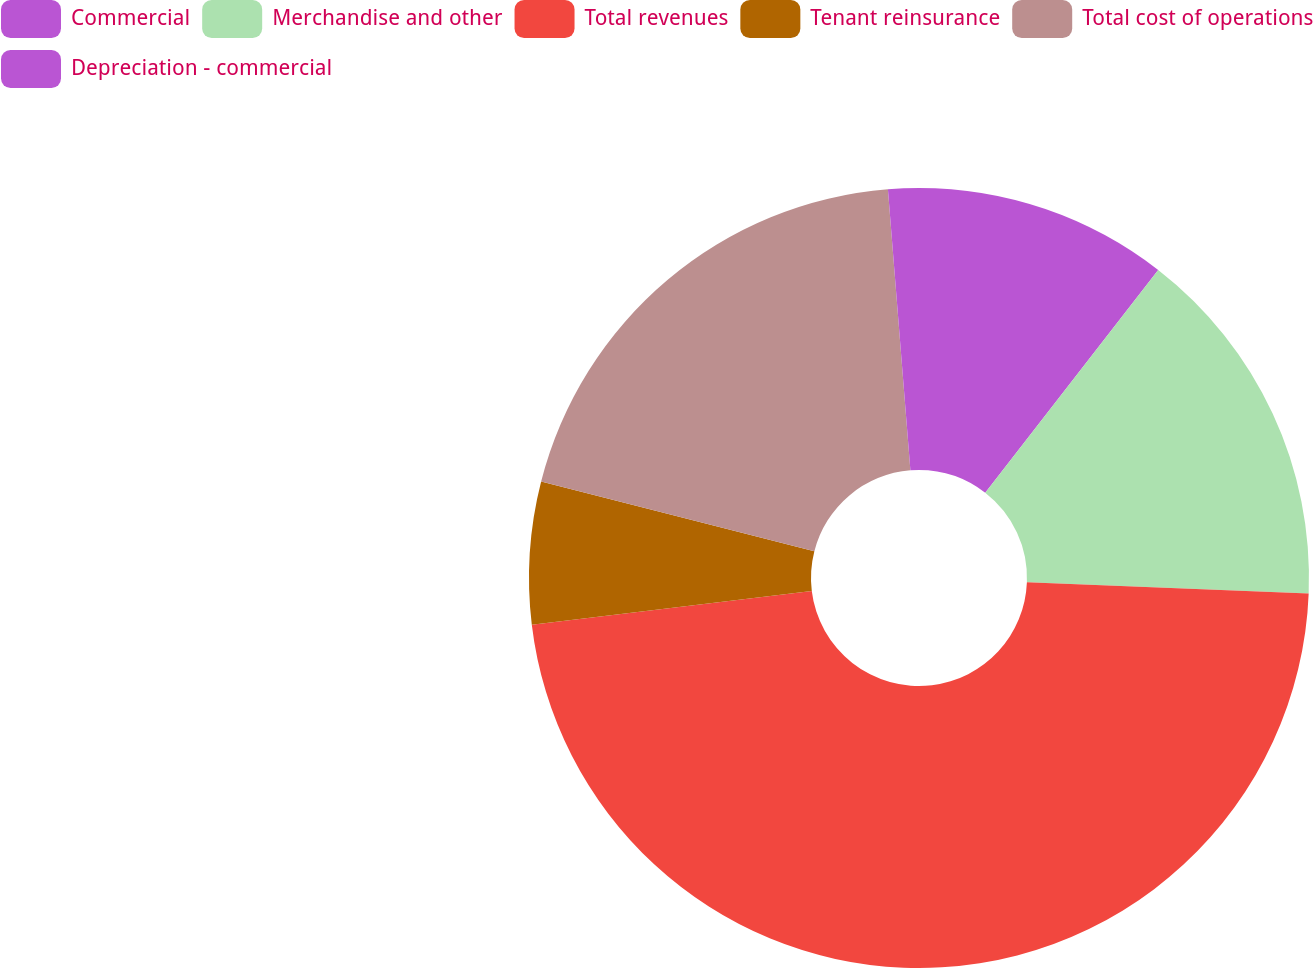Convert chart to OTSL. <chart><loc_0><loc_0><loc_500><loc_500><pie_chart><fcel>Commercial<fcel>Merchandise and other<fcel>Total revenues<fcel>Tenant reinsurance<fcel>Total cost of operations<fcel>Depreciation - commercial<nl><fcel>10.51%<fcel>15.13%<fcel>47.46%<fcel>5.89%<fcel>19.75%<fcel>1.27%<nl></chart> 